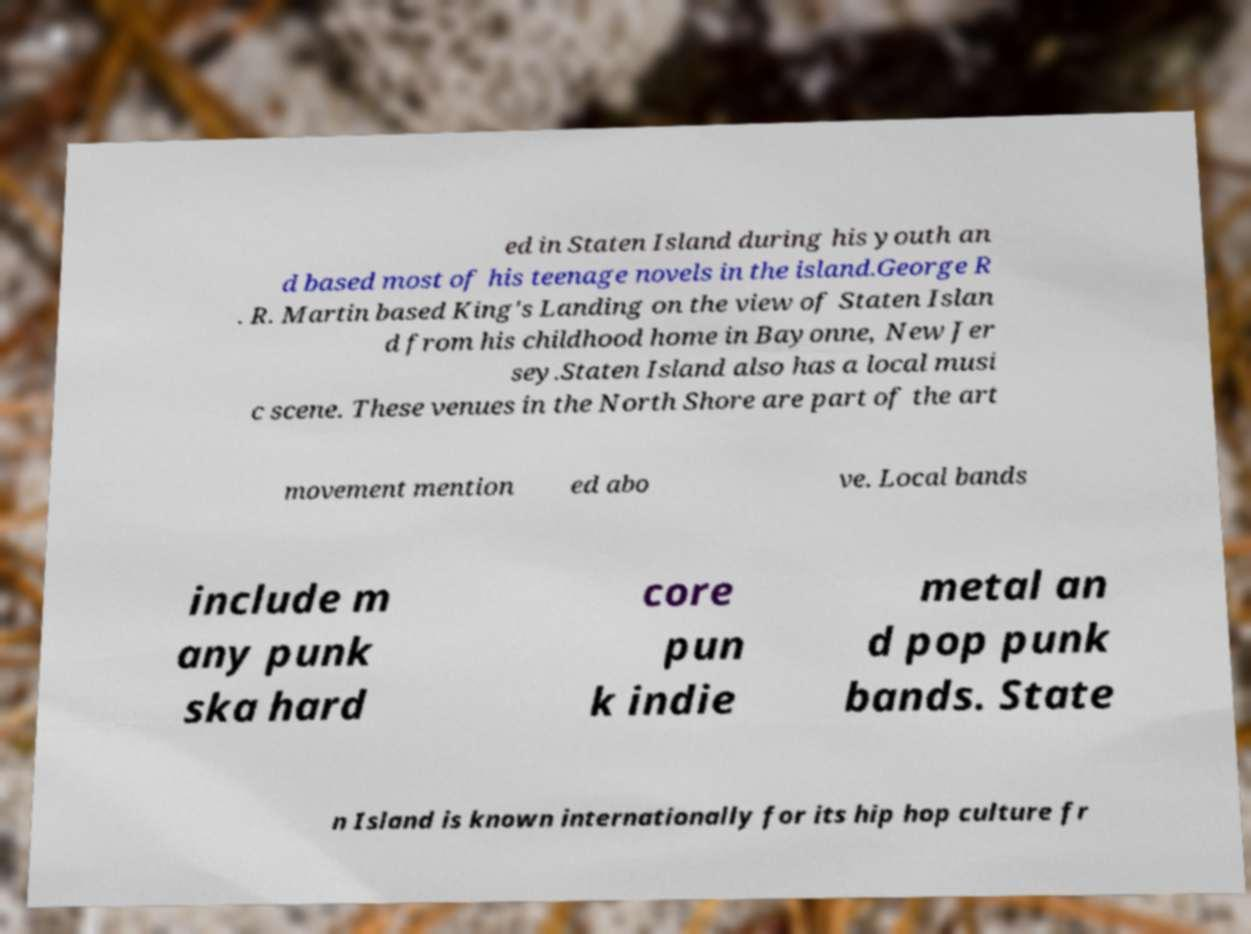For documentation purposes, I need the text within this image transcribed. Could you provide that? ed in Staten Island during his youth an d based most of his teenage novels in the island.George R . R. Martin based King's Landing on the view of Staten Islan d from his childhood home in Bayonne, New Jer sey.Staten Island also has a local musi c scene. These venues in the North Shore are part of the art movement mention ed abo ve. Local bands include m any punk ska hard core pun k indie metal an d pop punk bands. State n Island is known internationally for its hip hop culture fr 